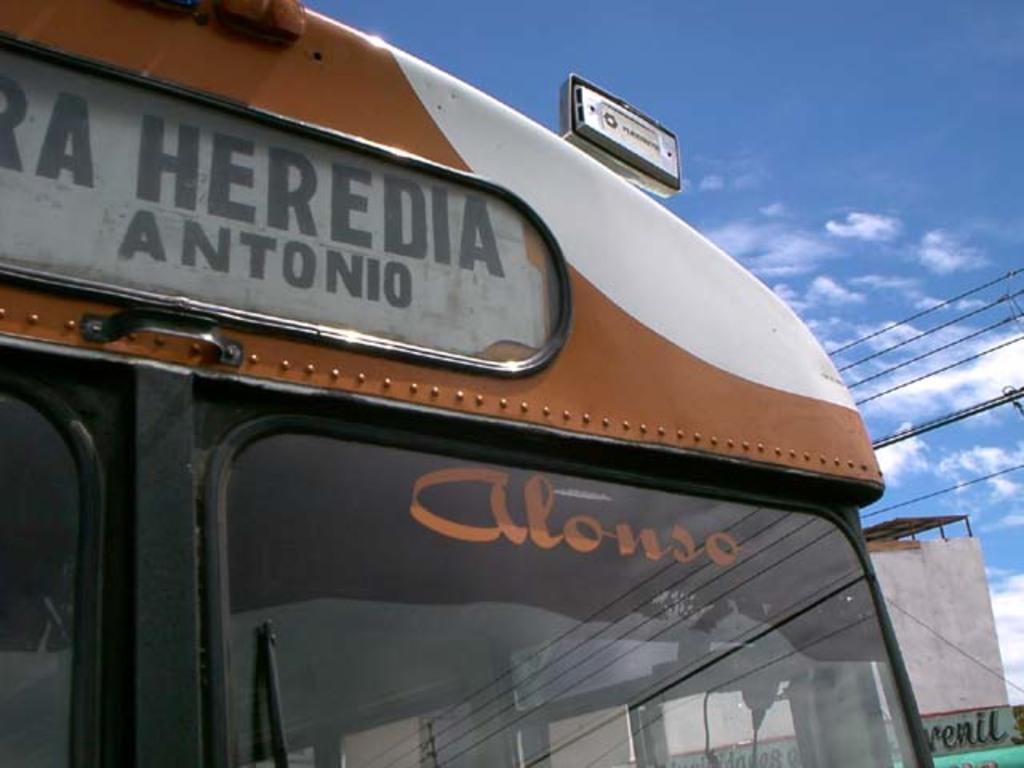In one or two sentences, can you explain what this image depicts? On the left side of the image a vehicle is there. On the right side of the image we can see a board, building, wires are there. At the top of the image clouds are present in the sky. 